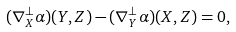Convert formula to latex. <formula><loc_0><loc_0><loc_500><loc_500>( \nabla ^ { \perp } _ { X } \alpha ) ( Y , Z ) - ( \nabla ^ { \perp } _ { Y } \alpha ) ( X , Z ) = 0 ,</formula> 